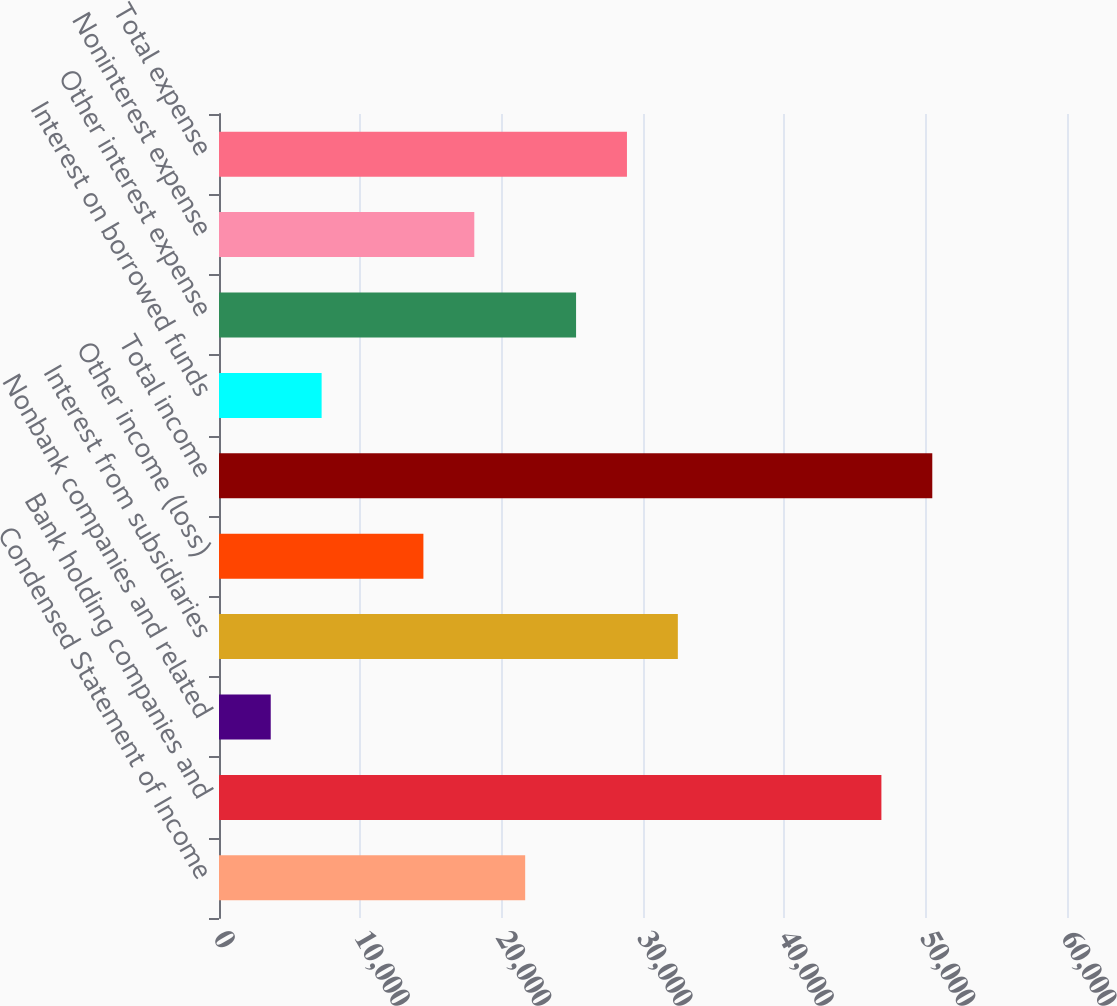<chart> <loc_0><loc_0><loc_500><loc_500><bar_chart><fcel>Condensed Statement of Income<fcel>Bank holding companies and<fcel>Nonbank companies and related<fcel>Interest from subsidiaries<fcel>Other income (loss)<fcel>Total income<fcel>Interest on borrowed funds<fcel>Other interest expense<fcel>Noninterest expense<fcel>Total expense<nl><fcel>21663.6<fcel>46867.8<fcel>3660.6<fcel>32465.4<fcel>14462.4<fcel>50468.4<fcel>7261.2<fcel>25264.2<fcel>18063<fcel>28864.8<nl></chart> 